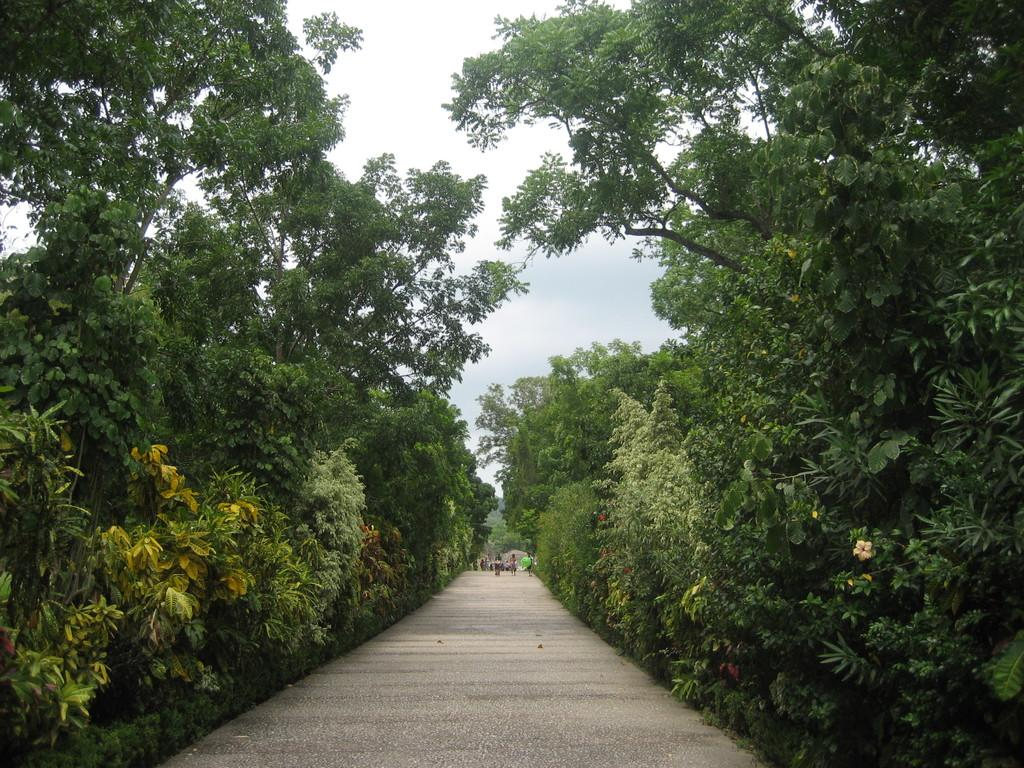What can be seen in the foreground of the image? There is a path in the foreground of the image. What type of vegetation is present alongside the path? There are trees on either side of the path. What is visible at the top of the image? The sky is visible at the top of the image. How many lizards are sitting on the selection of riddles in the image? There are no lizards or riddles present in the image. 